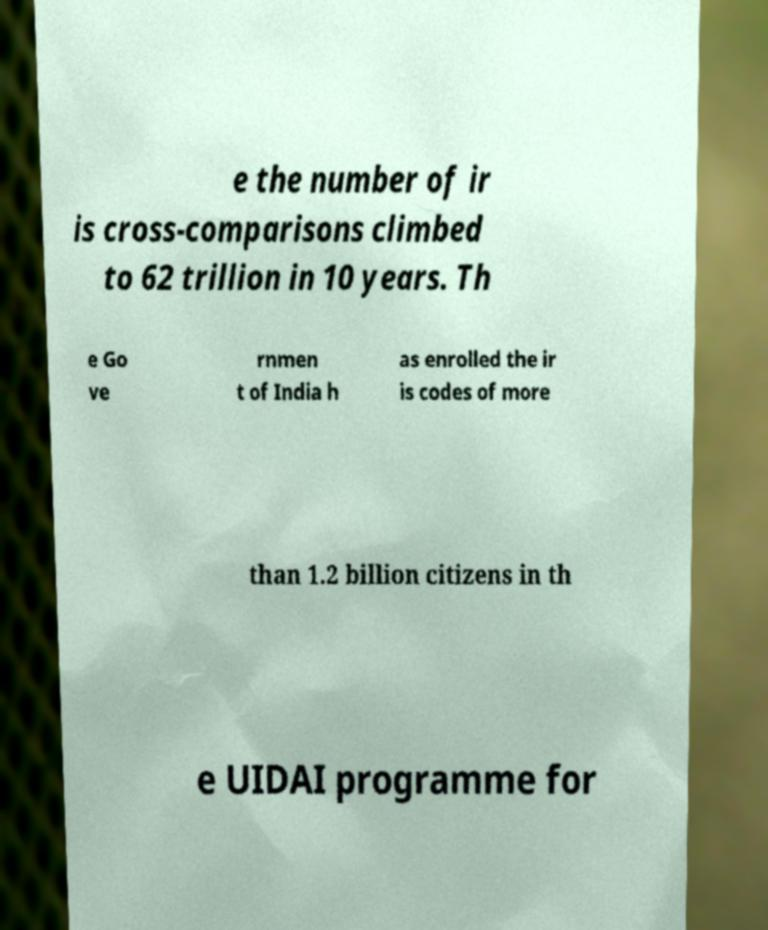There's text embedded in this image that I need extracted. Can you transcribe it verbatim? e the number of ir is cross-comparisons climbed to 62 trillion in 10 years. Th e Go ve rnmen t of India h as enrolled the ir is codes of more than 1.2 billion citizens in th e UIDAI programme for 